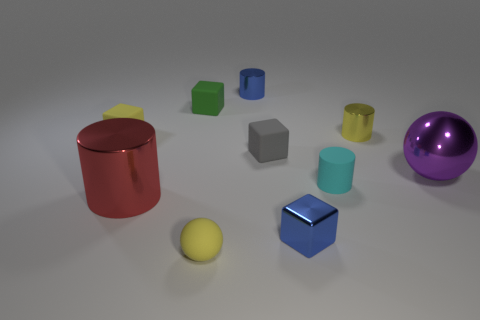What is the shape of the thing that is both in front of the small gray block and left of the tiny green cube?
Offer a terse response. Cylinder. There is a shiny cylinder that is on the left side of the small matte cylinder and in front of the small green rubber cube; what color is it?
Give a very brief answer. Red. Is the number of large purple objects behind the small cyan matte cylinder greater than the number of gray matte objects that are in front of the large shiny cylinder?
Provide a succinct answer. Yes. There is a tiny metallic cylinder that is to the left of the cyan rubber cylinder; what is its color?
Offer a very short reply. Blue. Do the tiny yellow thing in front of the metallic sphere and the big object behind the tiny rubber cylinder have the same shape?
Your answer should be compact. Yes. Are there any red matte objects that have the same size as the yellow rubber cube?
Make the answer very short. No. There is a yellow ball that is in front of the gray cube; what is its material?
Offer a very short reply. Rubber. Are the sphere in front of the red thing and the small blue block made of the same material?
Offer a very short reply. No. Are there any cyan things?
Make the answer very short. Yes. What is the color of the ball that is made of the same material as the small cyan thing?
Make the answer very short. Yellow. 